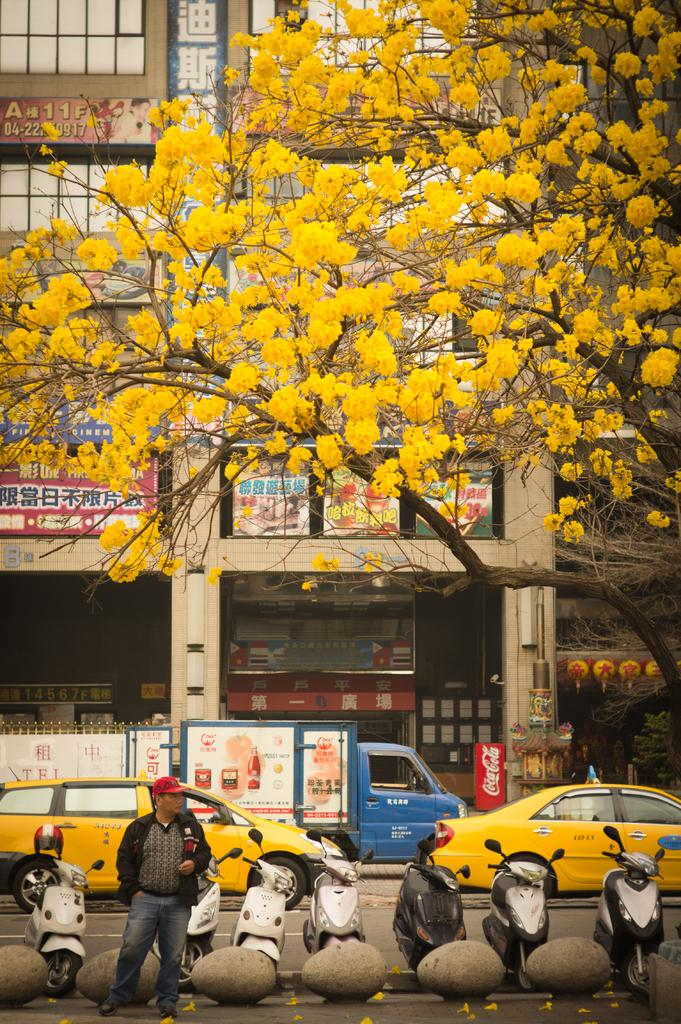<image>
Write a terse but informative summary of the picture. a street scene with a truck that has Tel on it in some foreign language. 